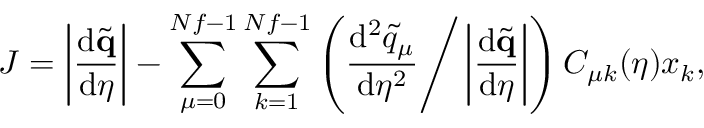Convert formula to latex. <formula><loc_0><loc_0><loc_500><loc_500>J = \left | \frac { d \tilde { q } } { d \eta } \right | - \sum _ { \mu = 0 } ^ { N f - 1 } \sum _ { k = 1 } ^ { N f - 1 } \left ( \frac { d ^ { 2 } \tilde { q } _ { \mu } } { d \eta ^ { 2 } } \Big / \left | \frac { d \tilde { q } } { d \eta } \right | \right ) C _ { \mu k } ( \eta ) x _ { k } ,</formula> 